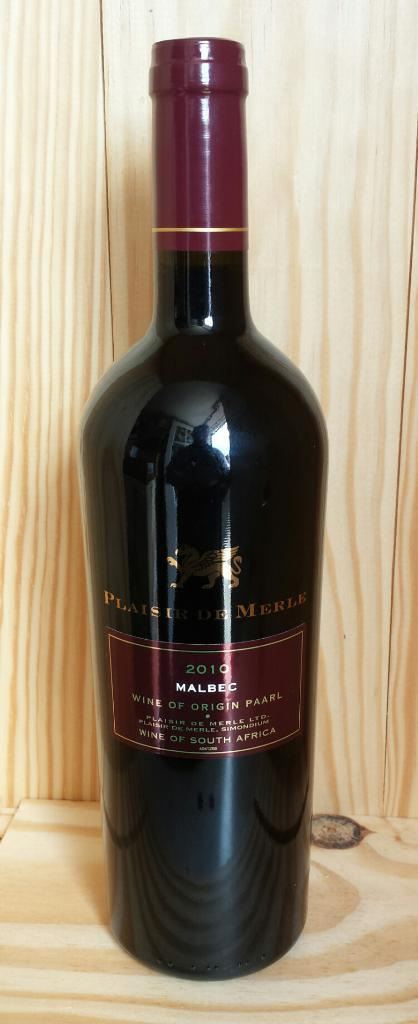<image>
Create a compact narrative representing the image presented. A 2010 bottle of Wine sitting on a wooden shelf or palette. 